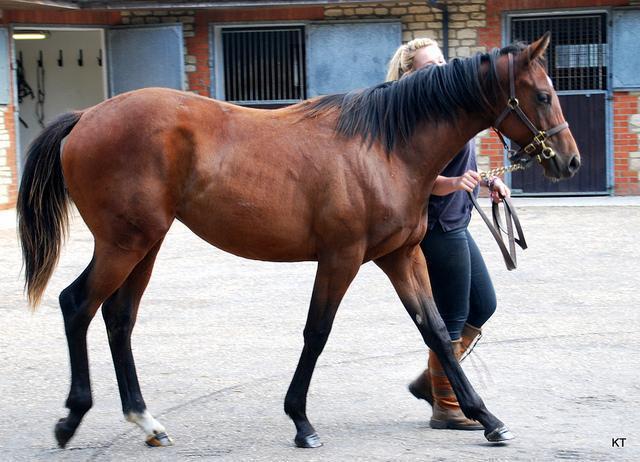How many horses are there?
Give a very brief answer. 1. 